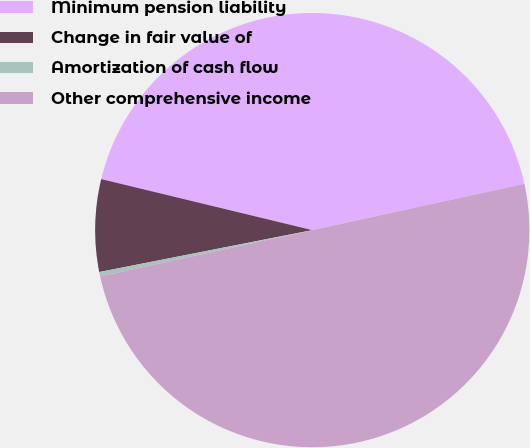<chart> <loc_0><loc_0><loc_500><loc_500><pie_chart><fcel>Minimum pension liability<fcel>Change in fair value of<fcel>Amortization of cash flow<fcel>Other comprehensive income<nl><fcel>42.8%<fcel>6.87%<fcel>0.33%<fcel>50.0%<nl></chart> 